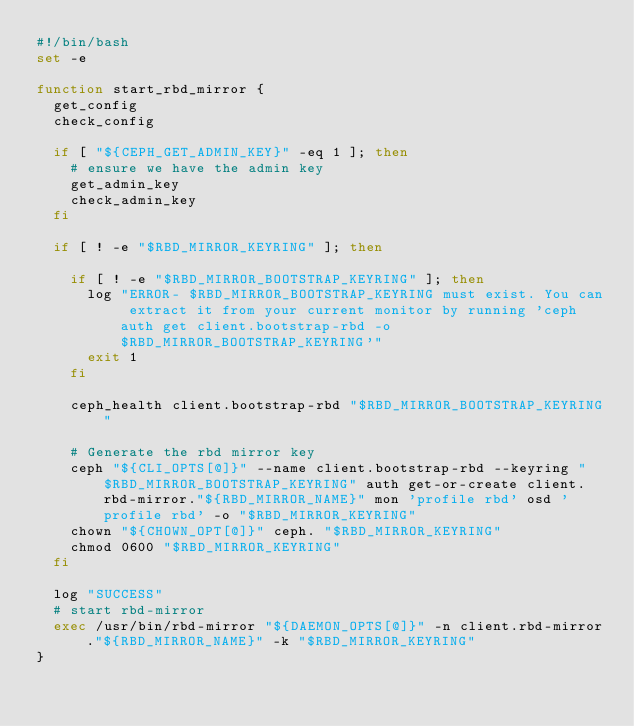Convert code to text. <code><loc_0><loc_0><loc_500><loc_500><_Bash_>#!/bin/bash
set -e

function start_rbd_mirror {
  get_config
  check_config

  if [ "${CEPH_GET_ADMIN_KEY}" -eq 1 ]; then
    # ensure we have the admin key
    get_admin_key
    check_admin_key
  fi

  if [ ! -e "$RBD_MIRROR_KEYRING" ]; then

    if [ ! -e "$RBD_MIRROR_BOOTSTRAP_KEYRING" ]; then
      log "ERROR- $RBD_MIRROR_BOOTSTRAP_KEYRING must exist. You can extract it from your current monitor by running 'ceph auth get client.bootstrap-rbd -o $RBD_MIRROR_BOOTSTRAP_KEYRING'"
      exit 1
    fi

    ceph_health client.bootstrap-rbd "$RBD_MIRROR_BOOTSTRAP_KEYRING"

    # Generate the rbd mirror key
    ceph "${CLI_OPTS[@]}" --name client.bootstrap-rbd --keyring "$RBD_MIRROR_BOOTSTRAP_KEYRING" auth get-or-create client.rbd-mirror."${RBD_MIRROR_NAME}" mon 'profile rbd' osd 'profile rbd' -o "$RBD_MIRROR_KEYRING"
    chown "${CHOWN_OPT[@]}" ceph. "$RBD_MIRROR_KEYRING"
    chmod 0600 "$RBD_MIRROR_KEYRING"
  fi

  log "SUCCESS"
  # start rbd-mirror
  exec /usr/bin/rbd-mirror "${DAEMON_OPTS[@]}" -n client.rbd-mirror."${RBD_MIRROR_NAME}" -k "$RBD_MIRROR_KEYRING"
}
</code> 